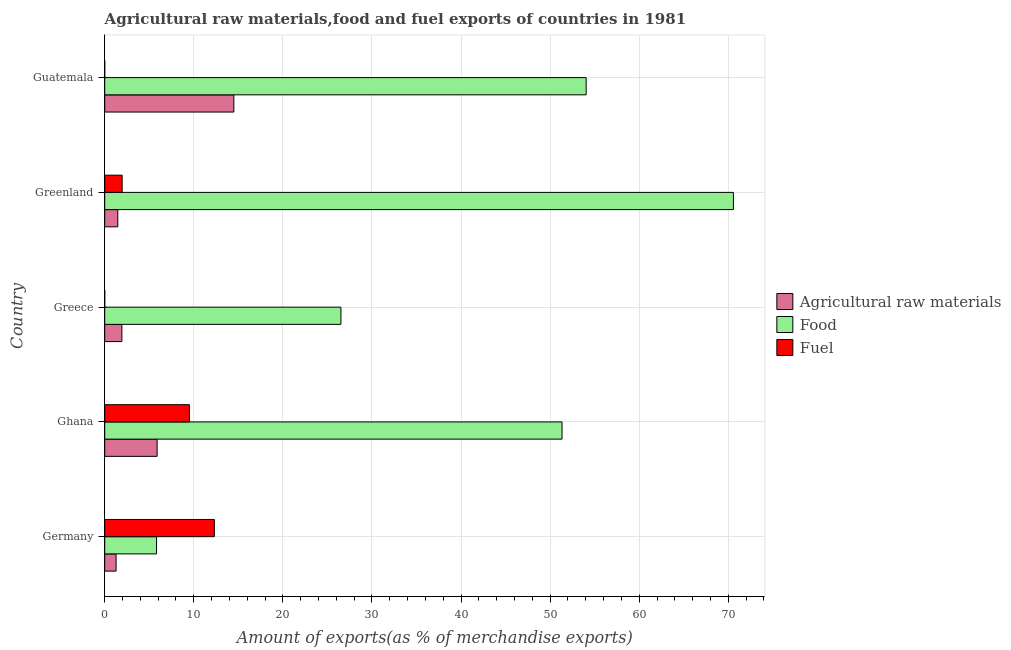How many different coloured bars are there?
Keep it short and to the point. 3. How many groups of bars are there?
Your answer should be very brief. 5. Are the number of bars per tick equal to the number of legend labels?
Your answer should be compact. Yes. What is the label of the 1st group of bars from the top?
Provide a succinct answer. Guatemala. In how many cases, is the number of bars for a given country not equal to the number of legend labels?
Make the answer very short. 0. What is the percentage of raw materials exports in Greenland?
Provide a short and direct response. 1.47. Across all countries, what is the maximum percentage of food exports?
Offer a terse response. 70.57. Across all countries, what is the minimum percentage of fuel exports?
Your answer should be compact. 6.23484075085997e-5. In which country was the percentage of food exports maximum?
Your response must be concise. Greenland. In which country was the percentage of food exports minimum?
Keep it short and to the point. Germany. What is the total percentage of food exports in the graph?
Your response must be concise. 208.27. What is the difference between the percentage of food exports in Ghana and that in Greece?
Provide a succinct answer. 24.82. What is the difference between the percentage of food exports in Guatemala and the percentage of fuel exports in Germany?
Ensure brevity in your answer.  41.73. What is the average percentage of food exports per country?
Offer a very short reply. 41.65. What is the difference between the percentage of food exports and percentage of raw materials exports in Ghana?
Provide a succinct answer. 45.45. What is the ratio of the percentage of food exports in Greece to that in Greenland?
Your response must be concise. 0.38. What is the difference between the highest and the second highest percentage of food exports?
Your answer should be very brief. 16.53. What is the difference between the highest and the lowest percentage of food exports?
Provide a succinct answer. 64.75. In how many countries, is the percentage of fuel exports greater than the average percentage of fuel exports taken over all countries?
Provide a succinct answer. 2. What does the 1st bar from the top in Greenland represents?
Keep it short and to the point. Fuel. What does the 2nd bar from the bottom in Greece represents?
Ensure brevity in your answer.  Food. How many bars are there?
Keep it short and to the point. 15. Are all the bars in the graph horizontal?
Provide a short and direct response. Yes. How many countries are there in the graph?
Ensure brevity in your answer.  5. What is the difference between two consecutive major ticks on the X-axis?
Ensure brevity in your answer.  10. Are the values on the major ticks of X-axis written in scientific E-notation?
Your response must be concise. No. Does the graph contain any zero values?
Offer a very short reply. No. Does the graph contain grids?
Ensure brevity in your answer.  Yes. How many legend labels are there?
Provide a short and direct response. 3. How are the legend labels stacked?
Keep it short and to the point. Vertical. What is the title of the graph?
Offer a terse response. Agricultural raw materials,food and fuel exports of countries in 1981. What is the label or title of the X-axis?
Give a very brief answer. Amount of exports(as % of merchandise exports). What is the Amount of exports(as % of merchandise exports) of Agricultural raw materials in Germany?
Offer a terse response. 1.28. What is the Amount of exports(as % of merchandise exports) in Food in Germany?
Your response must be concise. 5.82. What is the Amount of exports(as % of merchandise exports) of Fuel in Germany?
Offer a very short reply. 12.31. What is the Amount of exports(as % of merchandise exports) in Agricultural raw materials in Ghana?
Your answer should be compact. 5.88. What is the Amount of exports(as % of merchandise exports) in Food in Ghana?
Keep it short and to the point. 51.33. What is the Amount of exports(as % of merchandise exports) in Fuel in Ghana?
Ensure brevity in your answer.  9.51. What is the Amount of exports(as % of merchandise exports) of Agricultural raw materials in Greece?
Your answer should be compact. 1.93. What is the Amount of exports(as % of merchandise exports) of Food in Greece?
Keep it short and to the point. 26.51. What is the Amount of exports(as % of merchandise exports) of Fuel in Greece?
Ensure brevity in your answer.  0. What is the Amount of exports(as % of merchandise exports) in Agricultural raw materials in Greenland?
Offer a very short reply. 1.47. What is the Amount of exports(as % of merchandise exports) of Food in Greenland?
Keep it short and to the point. 70.57. What is the Amount of exports(as % of merchandise exports) in Fuel in Greenland?
Provide a succinct answer. 1.96. What is the Amount of exports(as % of merchandise exports) in Agricultural raw materials in Guatemala?
Offer a very short reply. 14.49. What is the Amount of exports(as % of merchandise exports) of Food in Guatemala?
Offer a very short reply. 54.04. What is the Amount of exports(as % of merchandise exports) of Fuel in Guatemala?
Your response must be concise. 6.23484075085997e-5. Across all countries, what is the maximum Amount of exports(as % of merchandise exports) in Agricultural raw materials?
Provide a short and direct response. 14.49. Across all countries, what is the maximum Amount of exports(as % of merchandise exports) in Food?
Provide a succinct answer. 70.57. Across all countries, what is the maximum Amount of exports(as % of merchandise exports) of Fuel?
Ensure brevity in your answer.  12.31. Across all countries, what is the minimum Amount of exports(as % of merchandise exports) of Agricultural raw materials?
Keep it short and to the point. 1.28. Across all countries, what is the minimum Amount of exports(as % of merchandise exports) in Food?
Offer a terse response. 5.82. Across all countries, what is the minimum Amount of exports(as % of merchandise exports) of Fuel?
Your answer should be compact. 6.23484075085997e-5. What is the total Amount of exports(as % of merchandise exports) of Agricultural raw materials in the graph?
Provide a succinct answer. 25.05. What is the total Amount of exports(as % of merchandise exports) in Food in the graph?
Your response must be concise. 208.27. What is the total Amount of exports(as % of merchandise exports) in Fuel in the graph?
Offer a terse response. 23.77. What is the difference between the Amount of exports(as % of merchandise exports) of Agricultural raw materials in Germany and that in Ghana?
Make the answer very short. -4.61. What is the difference between the Amount of exports(as % of merchandise exports) in Food in Germany and that in Ghana?
Offer a very short reply. -45.51. What is the difference between the Amount of exports(as % of merchandise exports) in Fuel in Germany and that in Ghana?
Offer a terse response. 2.8. What is the difference between the Amount of exports(as % of merchandise exports) of Agricultural raw materials in Germany and that in Greece?
Provide a short and direct response. -0.65. What is the difference between the Amount of exports(as % of merchandise exports) in Food in Germany and that in Greece?
Your response must be concise. -20.7. What is the difference between the Amount of exports(as % of merchandise exports) of Fuel in Germany and that in Greece?
Provide a short and direct response. 12.31. What is the difference between the Amount of exports(as % of merchandise exports) of Agricultural raw materials in Germany and that in Greenland?
Give a very brief answer. -0.19. What is the difference between the Amount of exports(as % of merchandise exports) of Food in Germany and that in Greenland?
Offer a terse response. -64.75. What is the difference between the Amount of exports(as % of merchandise exports) of Fuel in Germany and that in Greenland?
Keep it short and to the point. 10.35. What is the difference between the Amount of exports(as % of merchandise exports) of Agricultural raw materials in Germany and that in Guatemala?
Keep it short and to the point. -13.22. What is the difference between the Amount of exports(as % of merchandise exports) in Food in Germany and that in Guatemala?
Your answer should be very brief. -48.22. What is the difference between the Amount of exports(as % of merchandise exports) in Fuel in Germany and that in Guatemala?
Offer a very short reply. 12.31. What is the difference between the Amount of exports(as % of merchandise exports) of Agricultural raw materials in Ghana and that in Greece?
Ensure brevity in your answer.  3.96. What is the difference between the Amount of exports(as % of merchandise exports) of Food in Ghana and that in Greece?
Give a very brief answer. 24.82. What is the difference between the Amount of exports(as % of merchandise exports) of Fuel in Ghana and that in Greece?
Your answer should be compact. 9.51. What is the difference between the Amount of exports(as % of merchandise exports) of Agricultural raw materials in Ghana and that in Greenland?
Provide a succinct answer. 4.41. What is the difference between the Amount of exports(as % of merchandise exports) in Food in Ghana and that in Greenland?
Provide a short and direct response. -19.24. What is the difference between the Amount of exports(as % of merchandise exports) in Fuel in Ghana and that in Greenland?
Your response must be concise. 7.55. What is the difference between the Amount of exports(as % of merchandise exports) of Agricultural raw materials in Ghana and that in Guatemala?
Your response must be concise. -8.61. What is the difference between the Amount of exports(as % of merchandise exports) in Food in Ghana and that in Guatemala?
Your answer should be compact. -2.71. What is the difference between the Amount of exports(as % of merchandise exports) in Fuel in Ghana and that in Guatemala?
Make the answer very short. 9.51. What is the difference between the Amount of exports(as % of merchandise exports) in Agricultural raw materials in Greece and that in Greenland?
Your answer should be compact. 0.46. What is the difference between the Amount of exports(as % of merchandise exports) in Food in Greece and that in Greenland?
Give a very brief answer. -44.05. What is the difference between the Amount of exports(as % of merchandise exports) of Fuel in Greece and that in Greenland?
Make the answer very short. -1.96. What is the difference between the Amount of exports(as % of merchandise exports) of Agricultural raw materials in Greece and that in Guatemala?
Keep it short and to the point. -12.57. What is the difference between the Amount of exports(as % of merchandise exports) of Food in Greece and that in Guatemala?
Your answer should be very brief. -27.53. What is the difference between the Amount of exports(as % of merchandise exports) in Agricultural raw materials in Greenland and that in Guatemala?
Offer a very short reply. -13.03. What is the difference between the Amount of exports(as % of merchandise exports) in Food in Greenland and that in Guatemala?
Ensure brevity in your answer.  16.53. What is the difference between the Amount of exports(as % of merchandise exports) of Fuel in Greenland and that in Guatemala?
Provide a short and direct response. 1.96. What is the difference between the Amount of exports(as % of merchandise exports) in Agricultural raw materials in Germany and the Amount of exports(as % of merchandise exports) in Food in Ghana?
Provide a short and direct response. -50.06. What is the difference between the Amount of exports(as % of merchandise exports) in Agricultural raw materials in Germany and the Amount of exports(as % of merchandise exports) in Fuel in Ghana?
Offer a very short reply. -8.23. What is the difference between the Amount of exports(as % of merchandise exports) in Food in Germany and the Amount of exports(as % of merchandise exports) in Fuel in Ghana?
Give a very brief answer. -3.69. What is the difference between the Amount of exports(as % of merchandise exports) in Agricultural raw materials in Germany and the Amount of exports(as % of merchandise exports) in Food in Greece?
Provide a succinct answer. -25.24. What is the difference between the Amount of exports(as % of merchandise exports) of Agricultural raw materials in Germany and the Amount of exports(as % of merchandise exports) of Fuel in Greece?
Keep it short and to the point. 1.28. What is the difference between the Amount of exports(as % of merchandise exports) of Food in Germany and the Amount of exports(as % of merchandise exports) of Fuel in Greece?
Offer a very short reply. 5.82. What is the difference between the Amount of exports(as % of merchandise exports) of Agricultural raw materials in Germany and the Amount of exports(as % of merchandise exports) of Food in Greenland?
Keep it short and to the point. -69.29. What is the difference between the Amount of exports(as % of merchandise exports) in Agricultural raw materials in Germany and the Amount of exports(as % of merchandise exports) in Fuel in Greenland?
Offer a very short reply. -0.68. What is the difference between the Amount of exports(as % of merchandise exports) of Food in Germany and the Amount of exports(as % of merchandise exports) of Fuel in Greenland?
Ensure brevity in your answer.  3.86. What is the difference between the Amount of exports(as % of merchandise exports) of Agricultural raw materials in Germany and the Amount of exports(as % of merchandise exports) of Food in Guatemala?
Give a very brief answer. -52.76. What is the difference between the Amount of exports(as % of merchandise exports) of Agricultural raw materials in Germany and the Amount of exports(as % of merchandise exports) of Fuel in Guatemala?
Keep it short and to the point. 1.28. What is the difference between the Amount of exports(as % of merchandise exports) of Food in Germany and the Amount of exports(as % of merchandise exports) of Fuel in Guatemala?
Make the answer very short. 5.82. What is the difference between the Amount of exports(as % of merchandise exports) of Agricultural raw materials in Ghana and the Amount of exports(as % of merchandise exports) of Food in Greece?
Ensure brevity in your answer.  -20.63. What is the difference between the Amount of exports(as % of merchandise exports) of Agricultural raw materials in Ghana and the Amount of exports(as % of merchandise exports) of Fuel in Greece?
Your answer should be compact. 5.88. What is the difference between the Amount of exports(as % of merchandise exports) in Food in Ghana and the Amount of exports(as % of merchandise exports) in Fuel in Greece?
Offer a terse response. 51.33. What is the difference between the Amount of exports(as % of merchandise exports) in Agricultural raw materials in Ghana and the Amount of exports(as % of merchandise exports) in Food in Greenland?
Keep it short and to the point. -64.68. What is the difference between the Amount of exports(as % of merchandise exports) of Agricultural raw materials in Ghana and the Amount of exports(as % of merchandise exports) of Fuel in Greenland?
Offer a terse response. 3.92. What is the difference between the Amount of exports(as % of merchandise exports) in Food in Ghana and the Amount of exports(as % of merchandise exports) in Fuel in Greenland?
Provide a succinct answer. 49.37. What is the difference between the Amount of exports(as % of merchandise exports) of Agricultural raw materials in Ghana and the Amount of exports(as % of merchandise exports) of Food in Guatemala?
Provide a succinct answer. -48.16. What is the difference between the Amount of exports(as % of merchandise exports) in Agricultural raw materials in Ghana and the Amount of exports(as % of merchandise exports) in Fuel in Guatemala?
Keep it short and to the point. 5.88. What is the difference between the Amount of exports(as % of merchandise exports) of Food in Ghana and the Amount of exports(as % of merchandise exports) of Fuel in Guatemala?
Provide a succinct answer. 51.33. What is the difference between the Amount of exports(as % of merchandise exports) of Agricultural raw materials in Greece and the Amount of exports(as % of merchandise exports) of Food in Greenland?
Give a very brief answer. -68.64. What is the difference between the Amount of exports(as % of merchandise exports) in Agricultural raw materials in Greece and the Amount of exports(as % of merchandise exports) in Fuel in Greenland?
Your answer should be compact. -0.03. What is the difference between the Amount of exports(as % of merchandise exports) in Food in Greece and the Amount of exports(as % of merchandise exports) in Fuel in Greenland?
Offer a terse response. 24.56. What is the difference between the Amount of exports(as % of merchandise exports) in Agricultural raw materials in Greece and the Amount of exports(as % of merchandise exports) in Food in Guatemala?
Your answer should be very brief. -52.11. What is the difference between the Amount of exports(as % of merchandise exports) in Agricultural raw materials in Greece and the Amount of exports(as % of merchandise exports) in Fuel in Guatemala?
Offer a very short reply. 1.93. What is the difference between the Amount of exports(as % of merchandise exports) in Food in Greece and the Amount of exports(as % of merchandise exports) in Fuel in Guatemala?
Your answer should be compact. 26.51. What is the difference between the Amount of exports(as % of merchandise exports) of Agricultural raw materials in Greenland and the Amount of exports(as % of merchandise exports) of Food in Guatemala?
Provide a succinct answer. -52.57. What is the difference between the Amount of exports(as % of merchandise exports) in Agricultural raw materials in Greenland and the Amount of exports(as % of merchandise exports) in Fuel in Guatemala?
Make the answer very short. 1.47. What is the difference between the Amount of exports(as % of merchandise exports) of Food in Greenland and the Amount of exports(as % of merchandise exports) of Fuel in Guatemala?
Provide a succinct answer. 70.57. What is the average Amount of exports(as % of merchandise exports) of Agricultural raw materials per country?
Offer a terse response. 5.01. What is the average Amount of exports(as % of merchandise exports) in Food per country?
Offer a terse response. 41.65. What is the average Amount of exports(as % of merchandise exports) in Fuel per country?
Offer a very short reply. 4.75. What is the difference between the Amount of exports(as % of merchandise exports) in Agricultural raw materials and Amount of exports(as % of merchandise exports) in Food in Germany?
Your answer should be compact. -4.54. What is the difference between the Amount of exports(as % of merchandise exports) in Agricultural raw materials and Amount of exports(as % of merchandise exports) in Fuel in Germany?
Give a very brief answer. -11.03. What is the difference between the Amount of exports(as % of merchandise exports) in Food and Amount of exports(as % of merchandise exports) in Fuel in Germany?
Provide a short and direct response. -6.49. What is the difference between the Amount of exports(as % of merchandise exports) of Agricultural raw materials and Amount of exports(as % of merchandise exports) of Food in Ghana?
Your answer should be very brief. -45.45. What is the difference between the Amount of exports(as % of merchandise exports) in Agricultural raw materials and Amount of exports(as % of merchandise exports) in Fuel in Ghana?
Offer a terse response. -3.62. What is the difference between the Amount of exports(as % of merchandise exports) in Food and Amount of exports(as % of merchandise exports) in Fuel in Ghana?
Provide a short and direct response. 41.83. What is the difference between the Amount of exports(as % of merchandise exports) in Agricultural raw materials and Amount of exports(as % of merchandise exports) in Food in Greece?
Offer a very short reply. -24.59. What is the difference between the Amount of exports(as % of merchandise exports) of Agricultural raw materials and Amount of exports(as % of merchandise exports) of Fuel in Greece?
Your answer should be very brief. 1.93. What is the difference between the Amount of exports(as % of merchandise exports) in Food and Amount of exports(as % of merchandise exports) in Fuel in Greece?
Your response must be concise. 26.51. What is the difference between the Amount of exports(as % of merchandise exports) of Agricultural raw materials and Amount of exports(as % of merchandise exports) of Food in Greenland?
Keep it short and to the point. -69.1. What is the difference between the Amount of exports(as % of merchandise exports) in Agricultural raw materials and Amount of exports(as % of merchandise exports) in Fuel in Greenland?
Keep it short and to the point. -0.49. What is the difference between the Amount of exports(as % of merchandise exports) in Food and Amount of exports(as % of merchandise exports) in Fuel in Greenland?
Offer a terse response. 68.61. What is the difference between the Amount of exports(as % of merchandise exports) in Agricultural raw materials and Amount of exports(as % of merchandise exports) in Food in Guatemala?
Your answer should be compact. -39.54. What is the difference between the Amount of exports(as % of merchandise exports) of Agricultural raw materials and Amount of exports(as % of merchandise exports) of Fuel in Guatemala?
Ensure brevity in your answer.  14.49. What is the difference between the Amount of exports(as % of merchandise exports) of Food and Amount of exports(as % of merchandise exports) of Fuel in Guatemala?
Provide a short and direct response. 54.04. What is the ratio of the Amount of exports(as % of merchandise exports) of Agricultural raw materials in Germany to that in Ghana?
Offer a terse response. 0.22. What is the ratio of the Amount of exports(as % of merchandise exports) in Food in Germany to that in Ghana?
Your answer should be very brief. 0.11. What is the ratio of the Amount of exports(as % of merchandise exports) of Fuel in Germany to that in Ghana?
Ensure brevity in your answer.  1.29. What is the ratio of the Amount of exports(as % of merchandise exports) of Agricultural raw materials in Germany to that in Greece?
Provide a short and direct response. 0.66. What is the ratio of the Amount of exports(as % of merchandise exports) of Food in Germany to that in Greece?
Ensure brevity in your answer.  0.22. What is the ratio of the Amount of exports(as % of merchandise exports) of Fuel in Germany to that in Greece?
Make the answer very short. 4.04e+04. What is the ratio of the Amount of exports(as % of merchandise exports) in Agricultural raw materials in Germany to that in Greenland?
Your response must be concise. 0.87. What is the ratio of the Amount of exports(as % of merchandise exports) of Food in Germany to that in Greenland?
Make the answer very short. 0.08. What is the ratio of the Amount of exports(as % of merchandise exports) of Fuel in Germany to that in Greenland?
Offer a terse response. 6.29. What is the ratio of the Amount of exports(as % of merchandise exports) in Agricultural raw materials in Germany to that in Guatemala?
Offer a terse response. 0.09. What is the ratio of the Amount of exports(as % of merchandise exports) in Food in Germany to that in Guatemala?
Provide a short and direct response. 0.11. What is the ratio of the Amount of exports(as % of merchandise exports) in Fuel in Germany to that in Guatemala?
Make the answer very short. 1.97e+05. What is the ratio of the Amount of exports(as % of merchandise exports) of Agricultural raw materials in Ghana to that in Greece?
Offer a very short reply. 3.05. What is the ratio of the Amount of exports(as % of merchandise exports) in Food in Ghana to that in Greece?
Offer a terse response. 1.94. What is the ratio of the Amount of exports(as % of merchandise exports) of Fuel in Ghana to that in Greece?
Your answer should be compact. 3.12e+04. What is the ratio of the Amount of exports(as % of merchandise exports) of Agricultural raw materials in Ghana to that in Greenland?
Ensure brevity in your answer.  4. What is the ratio of the Amount of exports(as % of merchandise exports) in Food in Ghana to that in Greenland?
Your response must be concise. 0.73. What is the ratio of the Amount of exports(as % of merchandise exports) in Fuel in Ghana to that in Greenland?
Offer a very short reply. 4.86. What is the ratio of the Amount of exports(as % of merchandise exports) in Agricultural raw materials in Ghana to that in Guatemala?
Your answer should be compact. 0.41. What is the ratio of the Amount of exports(as % of merchandise exports) of Food in Ghana to that in Guatemala?
Provide a short and direct response. 0.95. What is the ratio of the Amount of exports(as % of merchandise exports) of Fuel in Ghana to that in Guatemala?
Provide a short and direct response. 1.52e+05. What is the ratio of the Amount of exports(as % of merchandise exports) in Agricultural raw materials in Greece to that in Greenland?
Provide a short and direct response. 1.31. What is the ratio of the Amount of exports(as % of merchandise exports) in Food in Greece to that in Greenland?
Offer a very short reply. 0.38. What is the ratio of the Amount of exports(as % of merchandise exports) in Agricultural raw materials in Greece to that in Guatemala?
Give a very brief answer. 0.13. What is the ratio of the Amount of exports(as % of merchandise exports) of Food in Greece to that in Guatemala?
Make the answer very short. 0.49. What is the ratio of the Amount of exports(as % of merchandise exports) of Fuel in Greece to that in Guatemala?
Provide a succinct answer. 4.89. What is the ratio of the Amount of exports(as % of merchandise exports) of Agricultural raw materials in Greenland to that in Guatemala?
Ensure brevity in your answer.  0.1. What is the ratio of the Amount of exports(as % of merchandise exports) in Food in Greenland to that in Guatemala?
Your answer should be very brief. 1.31. What is the ratio of the Amount of exports(as % of merchandise exports) in Fuel in Greenland to that in Guatemala?
Provide a short and direct response. 3.14e+04. What is the difference between the highest and the second highest Amount of exports(as % of merchandise exports) of Agricultural raw materials?
Provide a succinct answer. 8.61. What is the difference between the highest and the second highest Amount of exports(as % of merchandise exports) in Food?
Your answer should be very brief. 16.53. What is the difference between the highest and the second highest Amount of exports(as % of merchandise exports) of Fuel?
Your answer should be very brief. 2.8. What is the difference between the highest and the lowest Amount of exports(as % of merchandise exports) in Agricultural raw materials?
Your answer should be compact. 13.22. What is the difference between the highest and the lowest Amount of exports(as % of merchandise exports) in Food?
Ensure brevity in your answer.  64.75. What is the difference between the highest and the lowest Amount of exports(as % of merchandise exports) in Fuel?
Offer a very short reply. 12.31. 